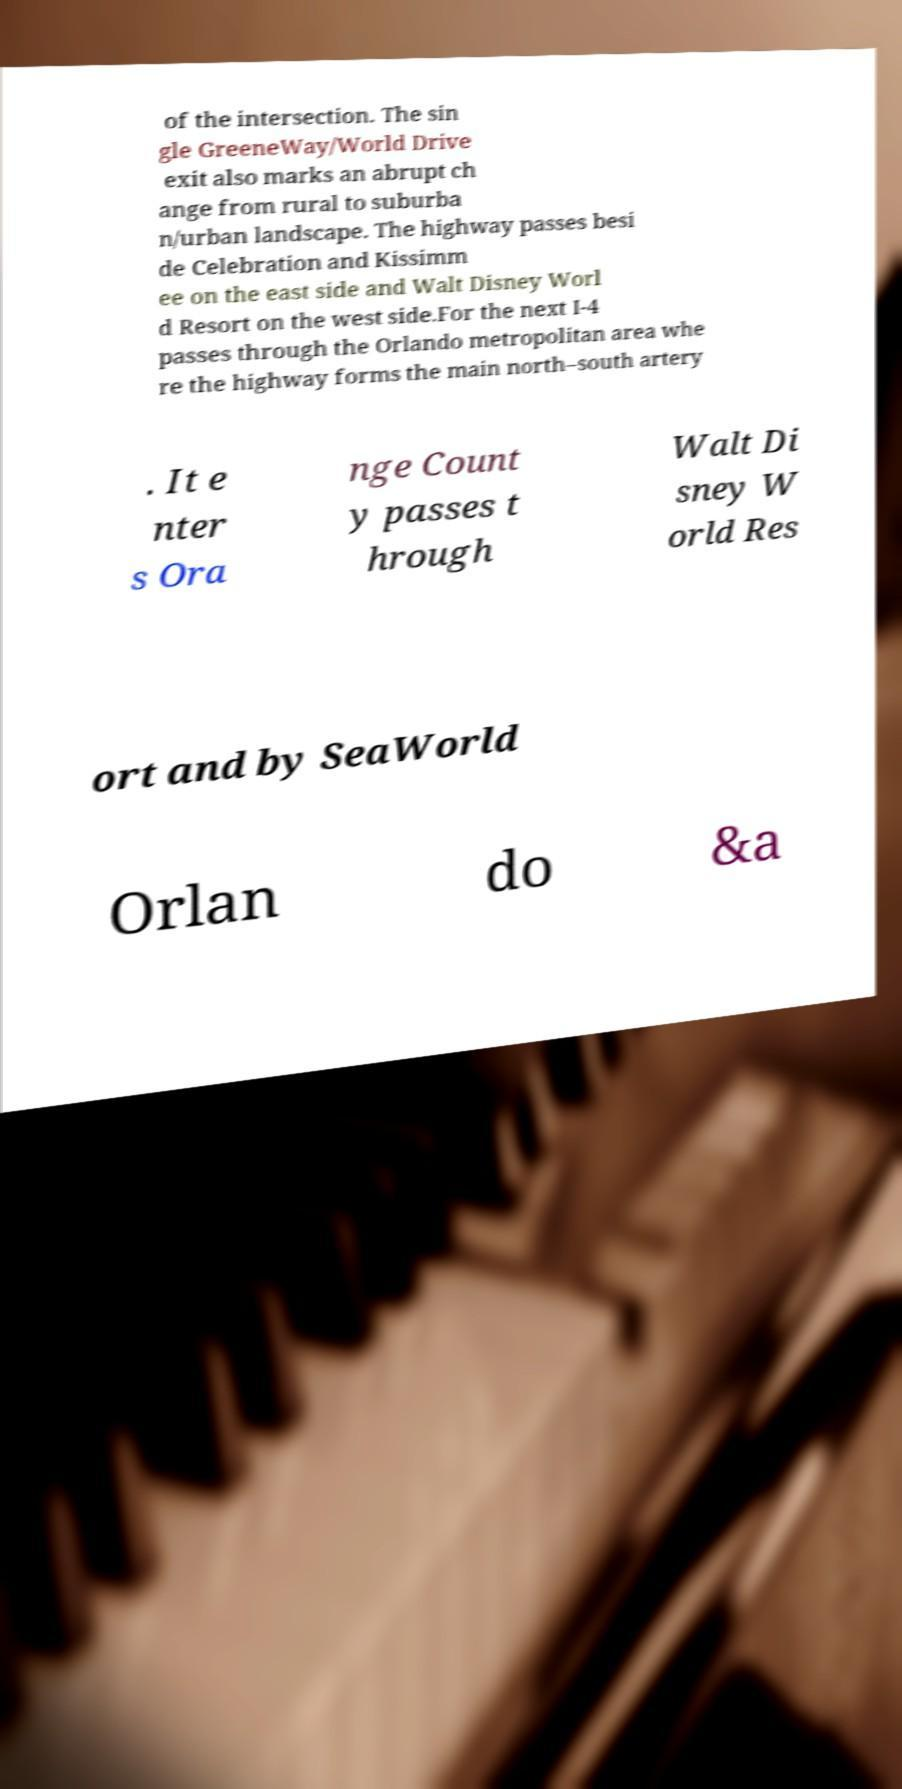Could you extract and type out the text from this image? of the intersection. The sin gle GreeneWay/World Drive exit also marks an abrupt ch ange from rural to suburba n/urban landscape. The highway passes besi de Celebration and Kissimm ee on the east side and Walt Disney Worl d Resort on the west side.For the next I-4 passes through the Orlando metropolitan area whe re the highway forms the main north–south artery . It e nter s Ora nge Count y passes t hrough Walt Di sney W orld Res ort and by SeaWorld Orlan do &a 